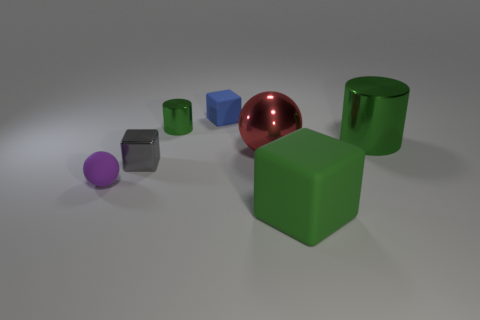There is a block that is the same color as the tiny cylinder; what material is it?
Offer a terse response. Rubber. Does the purple thing have the same material as the gray thing?
Ensure brevity in your answer.  No. What number of red shiny things are left of the tiny blue object on the right side of the small object that is in front of the gray metal block?
Make the answer very short. 0. Is there another thing that has the same material as the purple thing?
Your response must be concise. Yes. There is another cylinder that is the same color as the tiny metallic cylinder; what is its size?
Your response must be concise. Large. Are there fewer balls than big red objects?
Your answer should be very brief. No. Does the block that is in front of the gray object have the same color as the small metallic cylinder?
Make the answer very short. Yes. What material is the tiny cube that is behind the green cylinder that is to the left of the matte block that is in front of the small rubber sphere made of?
Your response must be concise. Rubber. Are there any small cylinders that have the same color as the big rubber thing?
Provide a short and direct response. Yes. Is the number of large red things that are behind the large red metal sphere less than the number of yellow rubber balls?
Offer a terse response. No. 